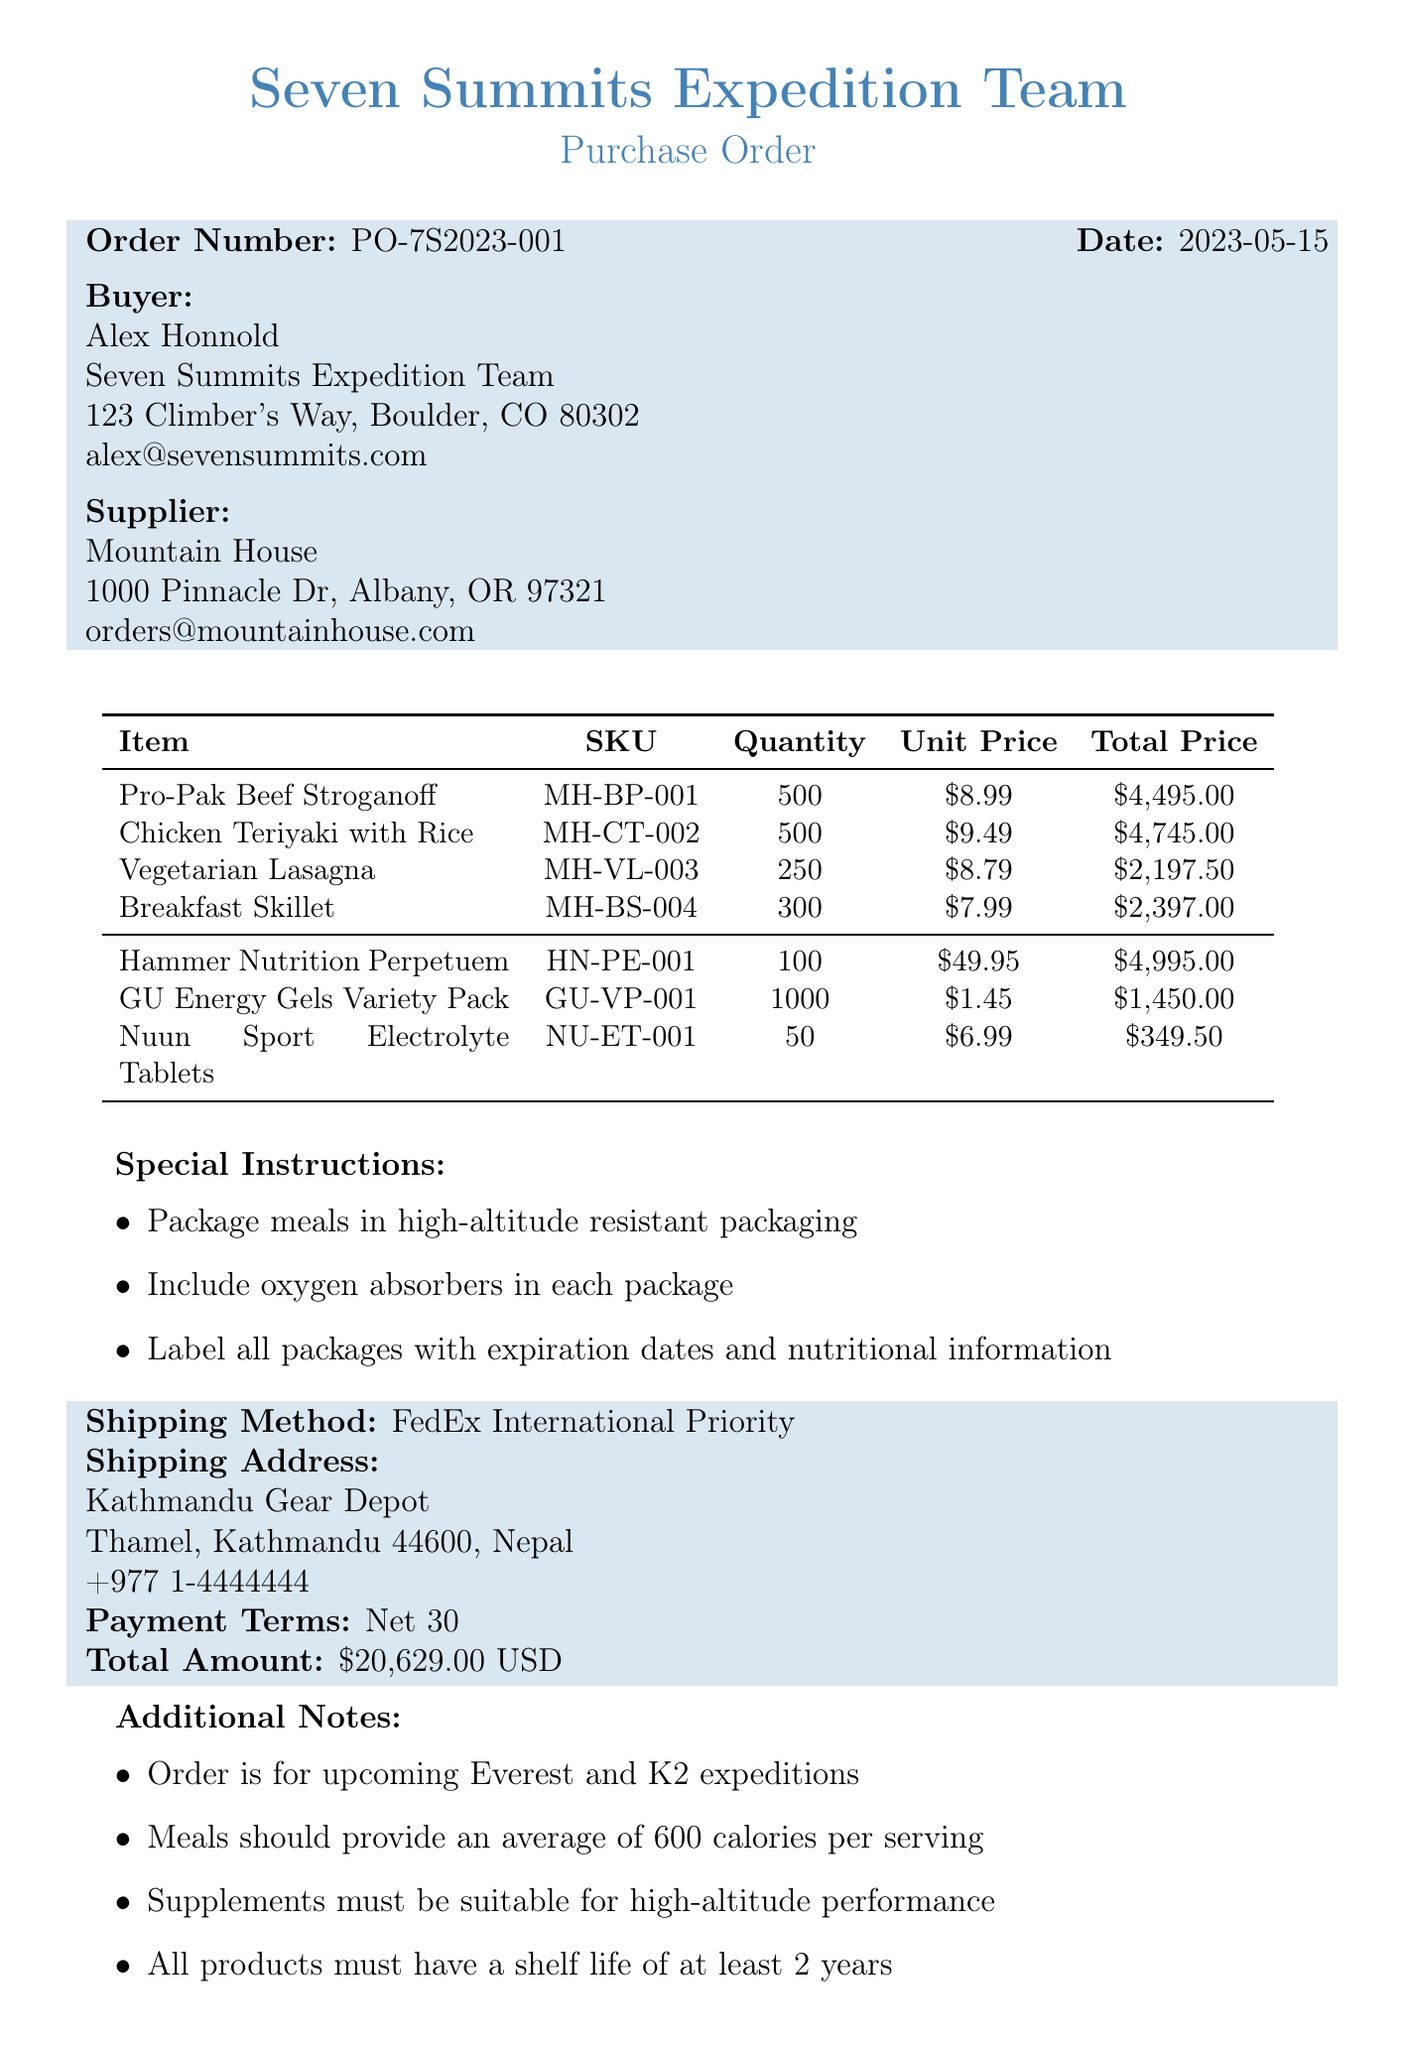what is the order number? The order number is stated explicitly at the beginning of the document.
Answer: PO-7S2023-001 who is the buyer? The buyer is listed in the document under the buyer section.
Answer: Alex Honnold what is the shipping method? The shipping method is included in the shipping information section of the document.
Answer: FedEx International Priority how many units of Chicken Teriyaki with Rice are ordered? The quantity of Chicken Teriyaki with Rice is specified in the items list.
Answer: 500 what is the total amount of the purchase order? The total amount is clearly mentioned in the payment details section at the end of the document.
Answer: 20629.00 USD what special packaging instructions are provided? The document lists specific special instructions related to packaging.
Answer: High-altitude resistant packaging what is the shelf life requirement for products? The shelf life requirement is mentioned in the additional notes of the document.
Answer: At least 2 years how many varieties of supplements are ordered? The document lists the number of different supplement items included.
Answer: 3 varieties which address is specified for shipping? The shipping address is detailed towards the end of the document.
Answer: Kathmandu Gear Depot, Thamel, Kathmandu 44600, Nepal 